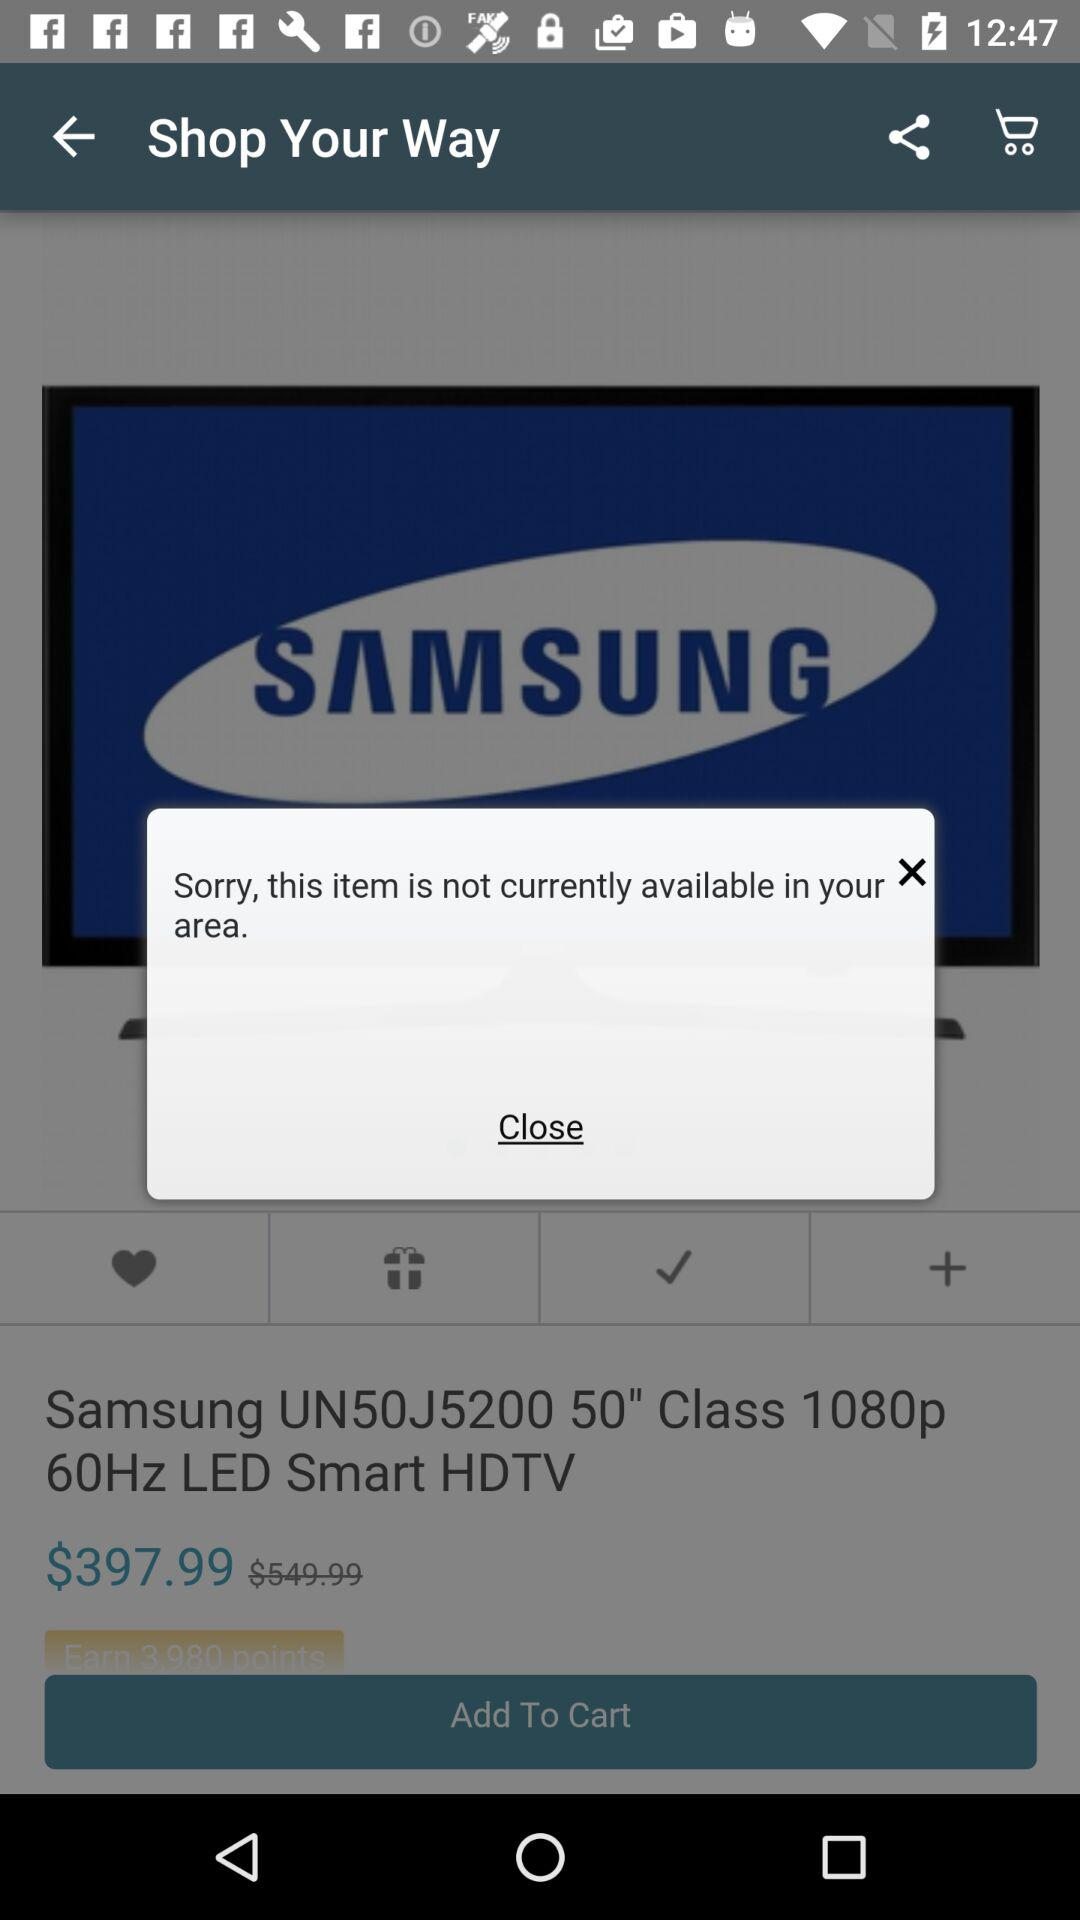What is the price of the "Samsung UN50J5200 50" Class 1080p 60Hz LED Smart HDTV"? The price is $397.99. 